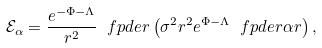<formula> <loc_0><loc_0><loc_500><loc_500>\mathcal { E } _ { \alpha } = \frac { e ^ { - \Phi - \Lambda } } { r ^ { 2 } } \ f p d e { r } \left ( \sigma ^ { 2 } r ^ { 2 } e ^ { \Phi - \Lambda } \ f p d e r { \alpha } { r } \right ) ,</formula> 